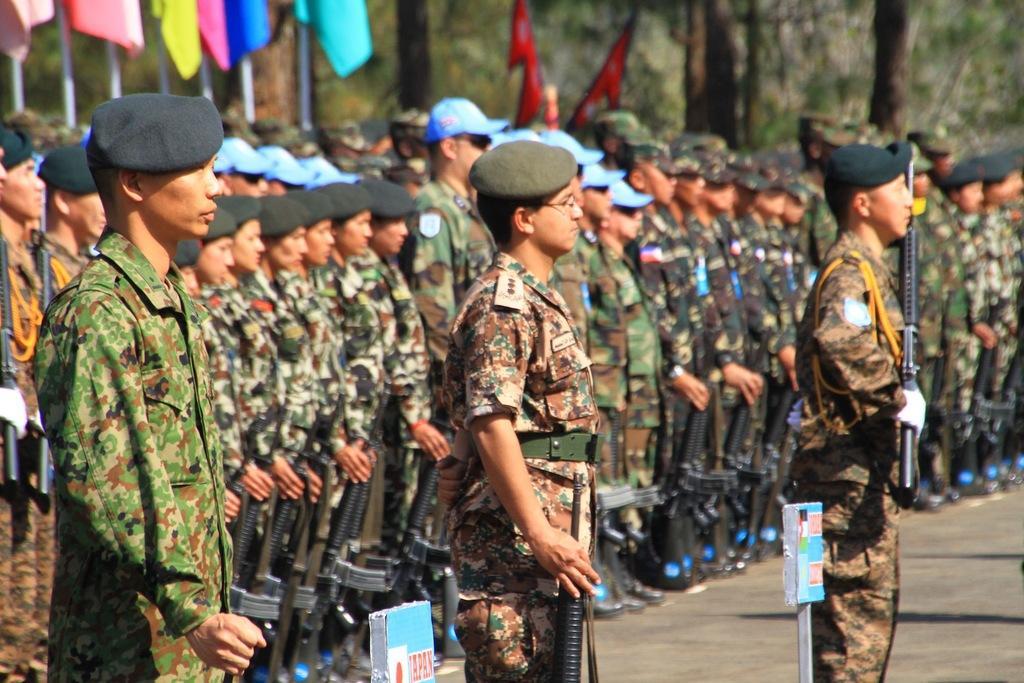How would you summarize this image in a sentence or two? Here we can see people. These people wore military dresses, caps and holding guns. Background it is blur. We can see flags and trees. These are boards and rod. 